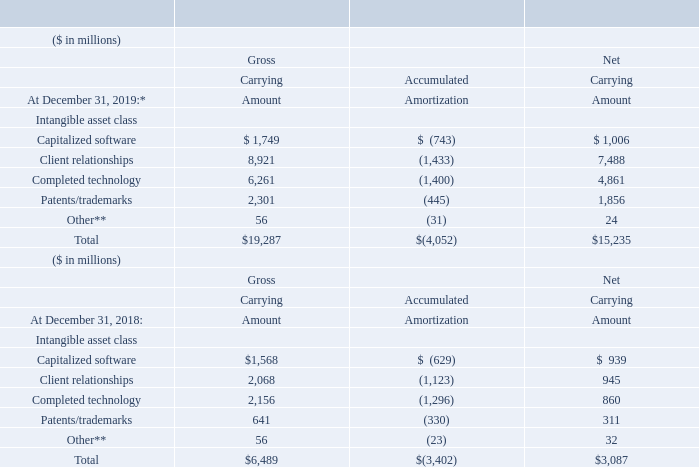Intangible Assets
The following table presents the company’s intangible asset balances by major asset class.
* Amounts as of December 31, 2019 include a decrease of $42 million in net intangible asset balances due to foreign currency translation. There was no foreign currency impact on net intangible assets for the year ended December 31, 2018.
** Other intangibles are primarily acquired proprietary and nonproprietary business processes, methodologies and systems.
What was the additional inclusion in net intangible asset balance due to foreign currency translation? Include a decrease of $42 million in net intangible asset balances due to foreign currency translation. What are the types of other intangibles? Other intangibles are primarily acquired proprietary and nonproprietary business processes, methodologies and systems. What was the gross carrying amount of total intangible assets in 2019?
Answer scale should be: million. $ 1,749. What is the increase / (decrease) in the net capitalized software from 2018 to 2019?
Answer scale should be: million. 1,006 - 939
Answer: 67. What is the average net client relationships in 2019 and 2018?
Answer scale should be: million. (7,488 + 945) / 2
Answer: 4216.5. What is the percentage increase / (decrease)  in net Completed technology from 2018 to 2019?
Answer scale should be: percent. (4,861 - 860)/860
Answer: 465.23. 